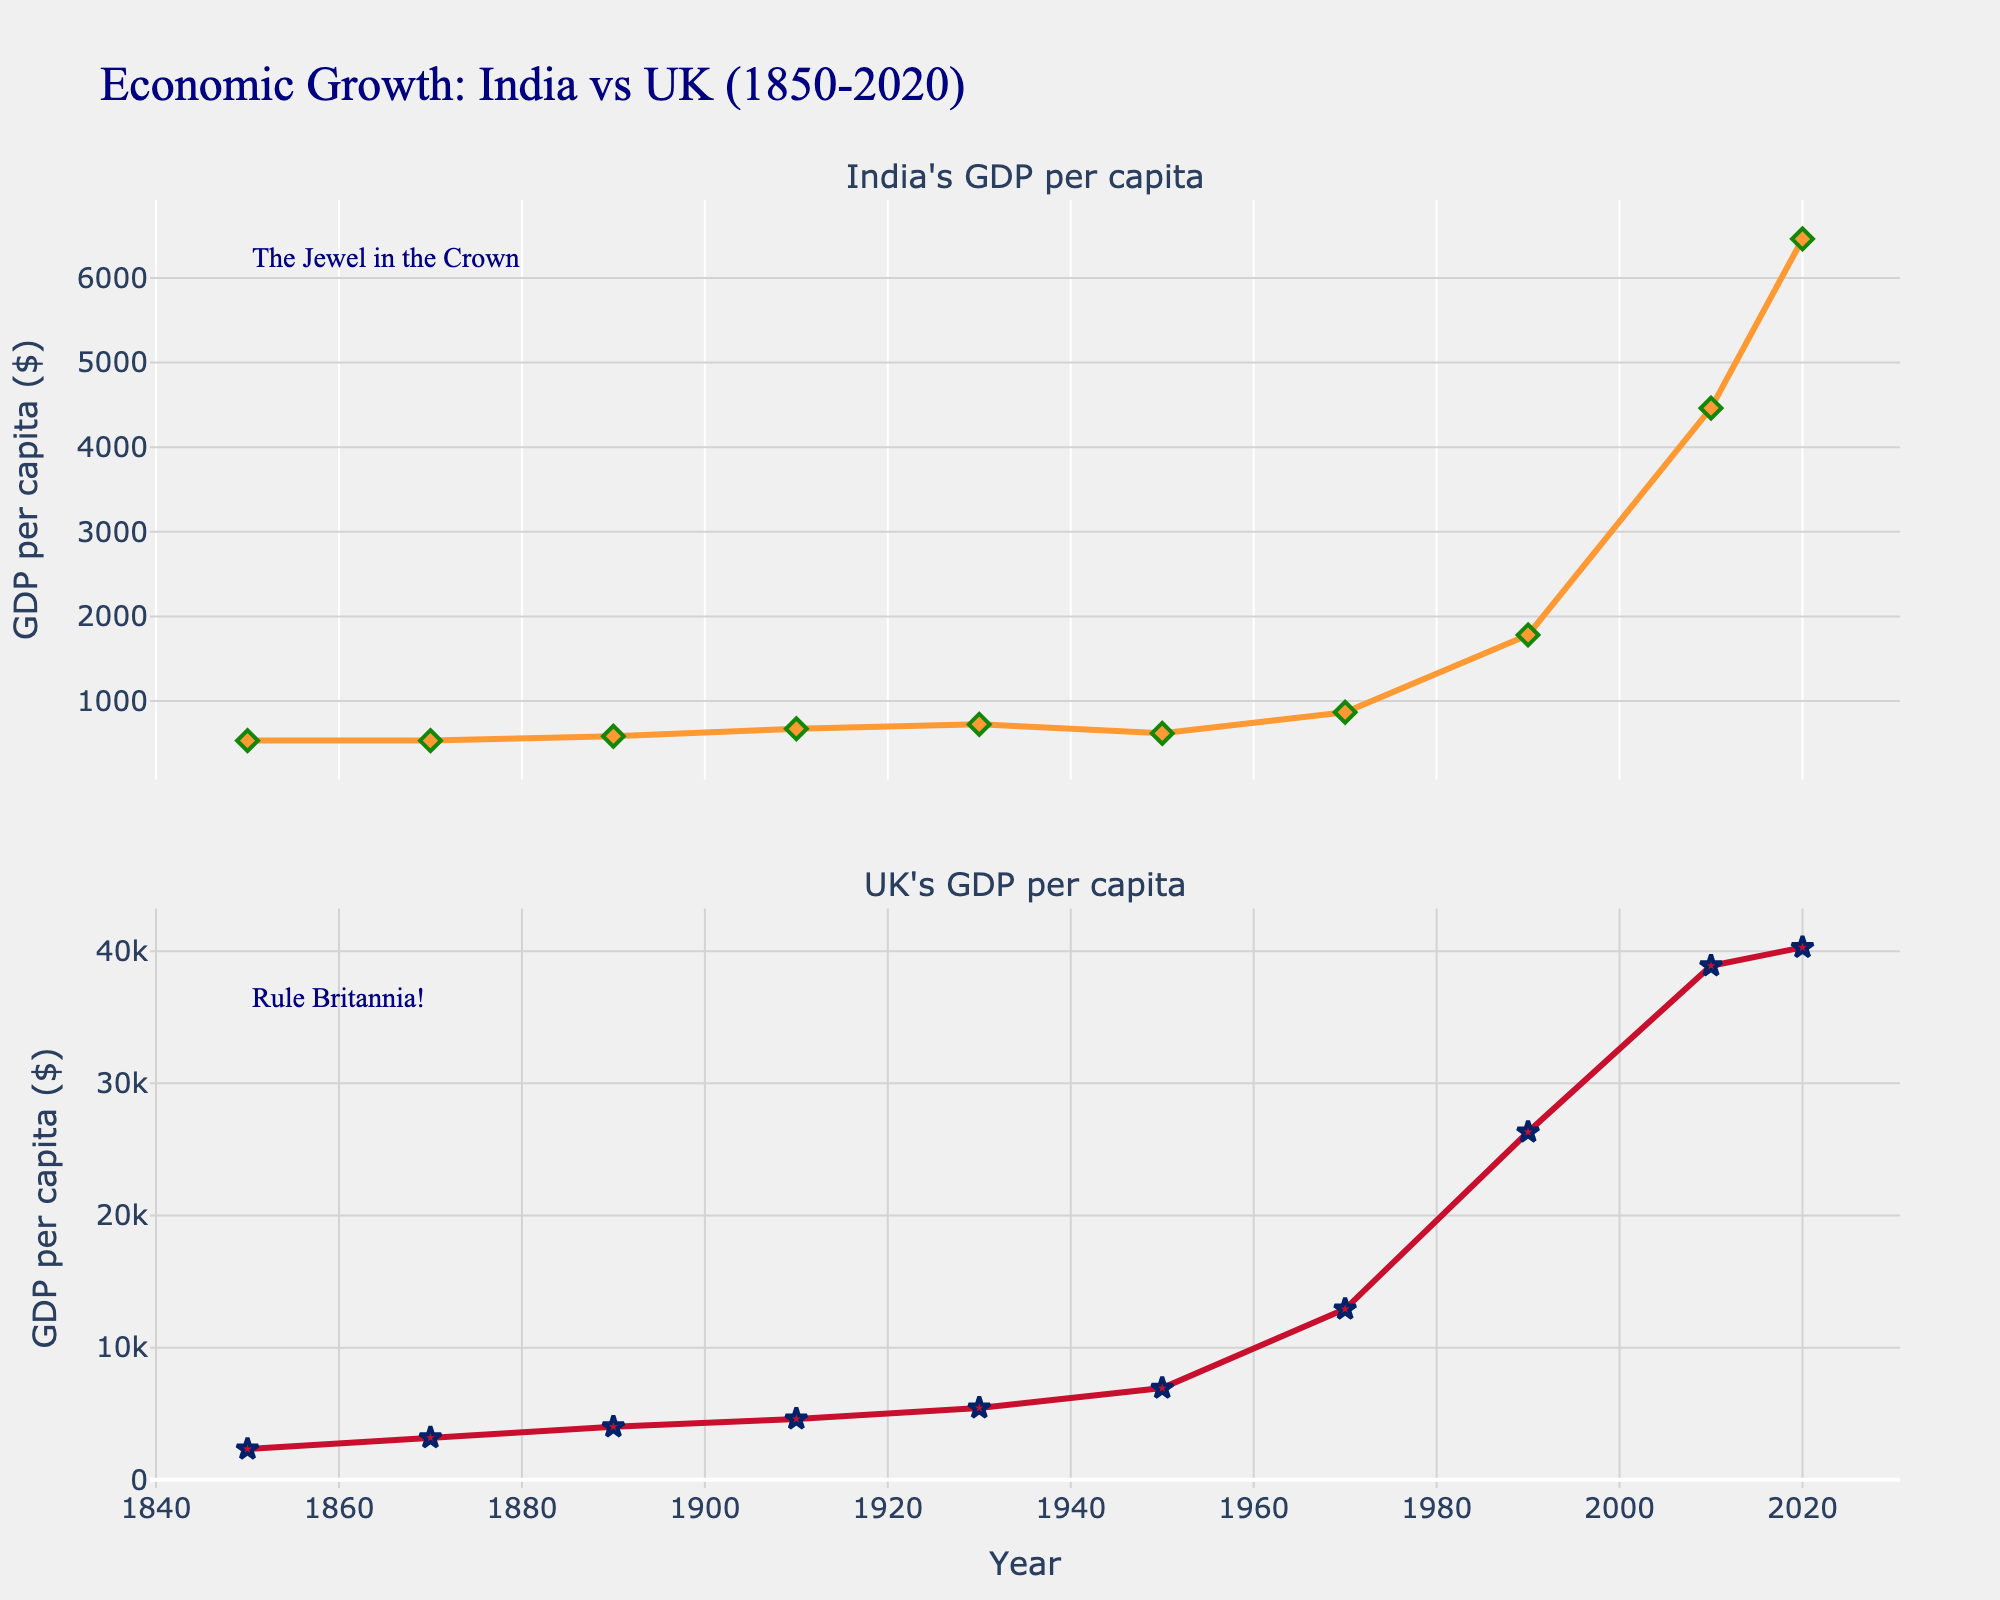How many years are displayed in the figure? There are data points for the years 1850, 1870, 1890, 1910, 1930, 1950, 1970, 1990, 2010, and 2020, making a total of 10 years displayed.
Answer: 10 What is the title of the figure? The title of the figure is prominently displayed at the top and reads "Economic Growth: India vs UK (1850-2020)".
Answer: Economic Growth: India vs UK (1850-2020) Which country had a higher GDP per capita in 1890? In 1890, the UK's GDP per capita was 4009, whereas India's was 584. By comparing these values, we see that the UK's GDP per capita was higher.
Answer: UK When did India's GDP per capita first exceed 1000 USD? India's GDP per capita first exceeded 1000 USD in the year 1990, as seen in the figure where the GDP per capita value is 1782 in 1990.
Answer: 1990 What's the difference in GDP per capita between India and the UK in 1910? In 1910, India's GDP per capita was 673 and the UK's GDP per capita was 4611. The difference can be calculated as 4611 - 673.
Answer: 3938 What is India's GDP per capita in 1950, and how does it compare to that in 1930? India's GDP per capita in 1950 is 619, while in 1930 it was 726. 619 is less than 726, indicating a decrease.
Answer: 619, Decrease In which year did both countries record their highest GDP per capita according to the figure? The figure shows that the highest GDP per capita for both countries was recorded in 2020, with India at 6461 and the UK at 40284.
Answer: 2020 How much did the UK's GDP per capita grow from 1850 to 2020? The UK's GDP per capita in 1850 was 2330, and in 2020 it was 40284. To find the growth, subtract 2330 from 40284.
Answer: 37954 Describe the trend of India's GDP per capita from 1850 to 2020. Initially stable from 1850 to around 1930, India's GDP per capita showed slight increases up to 1990, after which there was a significant rise, peaking in 2020.
Answer: Stable until 1930, slight increases until 1990, significant rise afterward What was the global context during the year indicated by the label "The Jewel in the Crown"? The label "The Jewel in the Crown" around the year 1850 refers to the period when India was considered the most valuable colony of the British Empire, highlighting economic conditions under colonial rule.
Answer: British Colonial Rule 